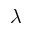<formula> <loc_0><loc_0><loc_500><loc_500>\lambda</formula> 